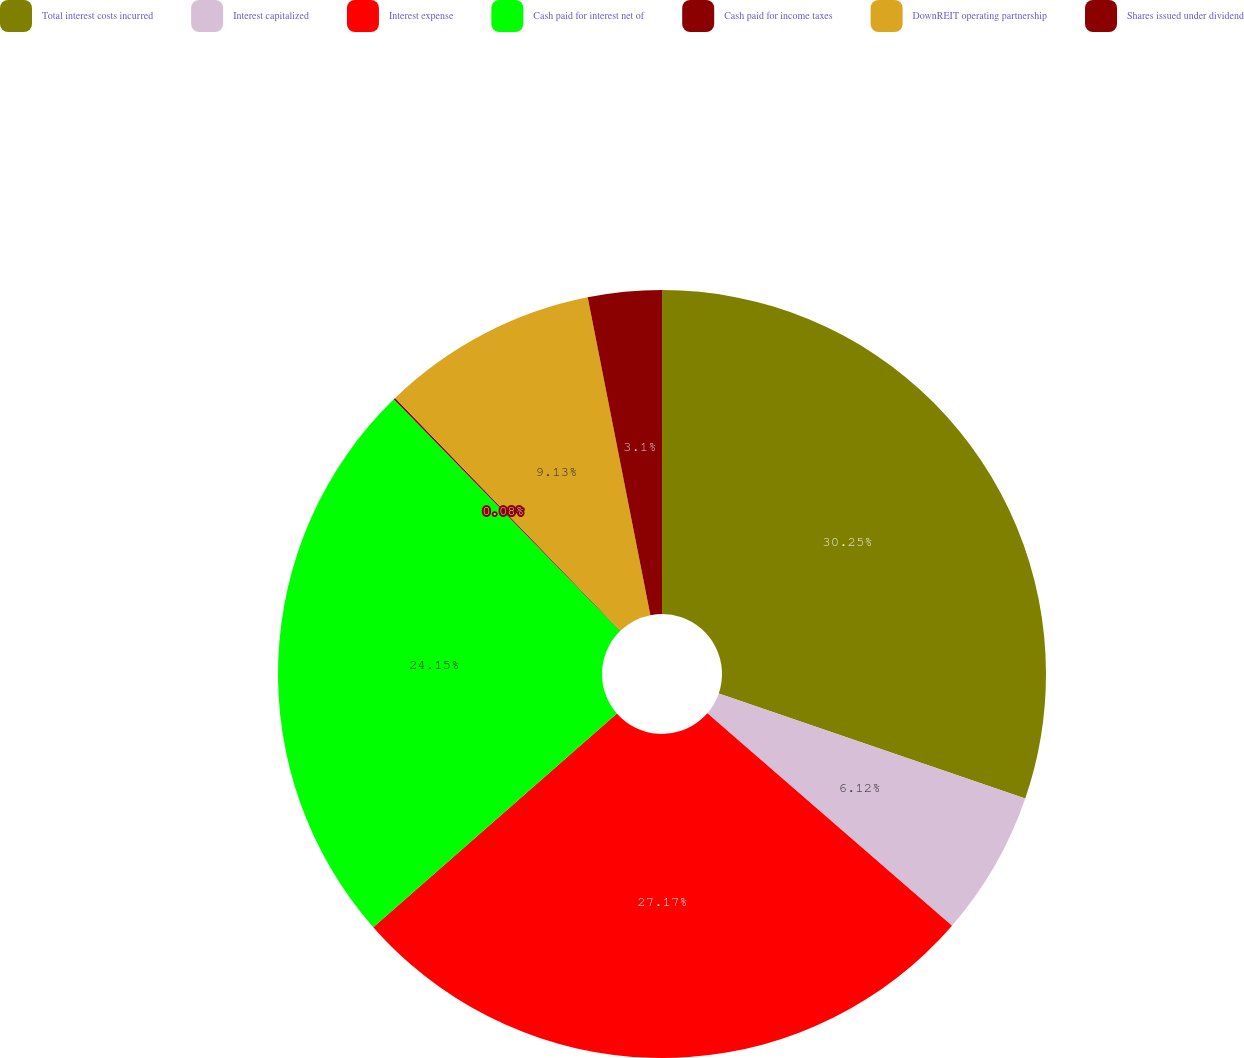Convert chart. <chart><loc_0><loc_0><loc_500><loc_500><pie_chart><fcel>Total interest costs incurred<fcel>Interest capitalized<fcel>Interest expense<fcel>Cash paid for interest net of<fcel>Cash paid for income taxes<fcel>DownREIT operating partnership<fcel>Shares issued under dividend<nl><fcel>30.26%<fcel>6.12%<fcel>27.17%<fcel>24.15%<fcel>0.08%<fcel>9.13%<fcel>3.1%<nl></chart> 